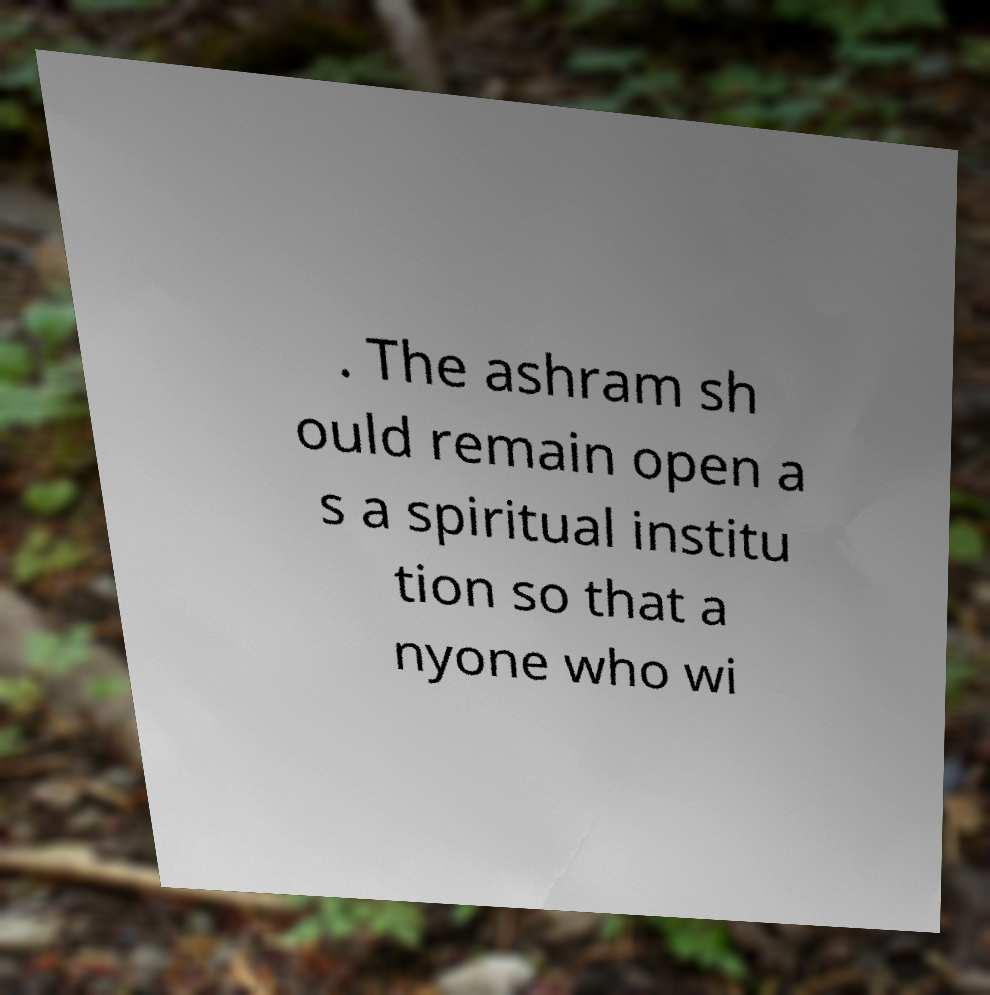There's text embedded in this image that I need extracted. Can you transcribe it verbatim? . The ashram sh ould remain open a s a spiritual institu tion so that a nyone who wi 